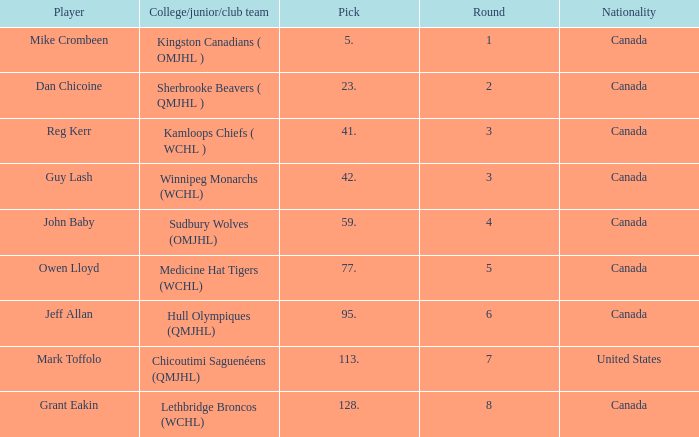Could you parse the entire table as a dict? {'header': ['Player', 'College/junior/club team', 'Pick', 'Round', 'Nationality'], 'rows': [['Mike Crombeen', 'Kingston Canadians ( OMJHL )', '5.', '1', 'Canada'], ['Dan Chicoine', 'Sherbrooke Beavers ( QMJHL )', '23.', '2', 'Canada'], ['Reg Kerr', 'Kamloops Chiefs ( WCHL )', '41.', '3', 'Canada'], ['Guy Lash', 'Winnipeg Monarchs (WCHL)', '42.', '3', 'Canada'], ['John Baby', 'Sudbury Wolves (OMJHL)', '59.', '4', 'Canada'], ['Owen Lloyd', 'Medicine Hat Tigers (WCHL)', '77.', '5', 'Canada'], ['Jeff Allan', 'Hull Olympiques (QMJHL)', '95.', '6', 'Canada'], ['Mark Toffolo', 'Chicoutimi Saguenéens (QMJHL)', '113.', '7', 'United States'], ['Grant Eakin', 'Lethbridge Broncos (WCHL)', '128.', '8', 'Canada']]} Which Round has a Player of dan chicoine, and a Pick larger than 23? None. 